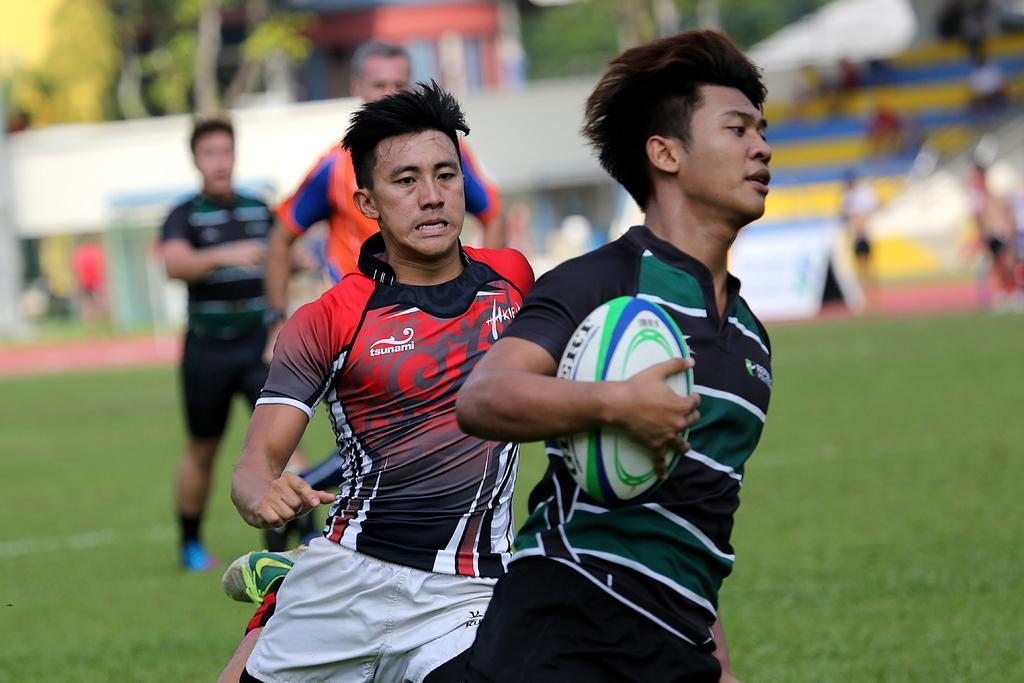Describe this image in one or two sentences. In this picture we can see four persons running on ground here in front person holding ball in his hand and in background we can see trees, some crowd of people but it is blurry. 